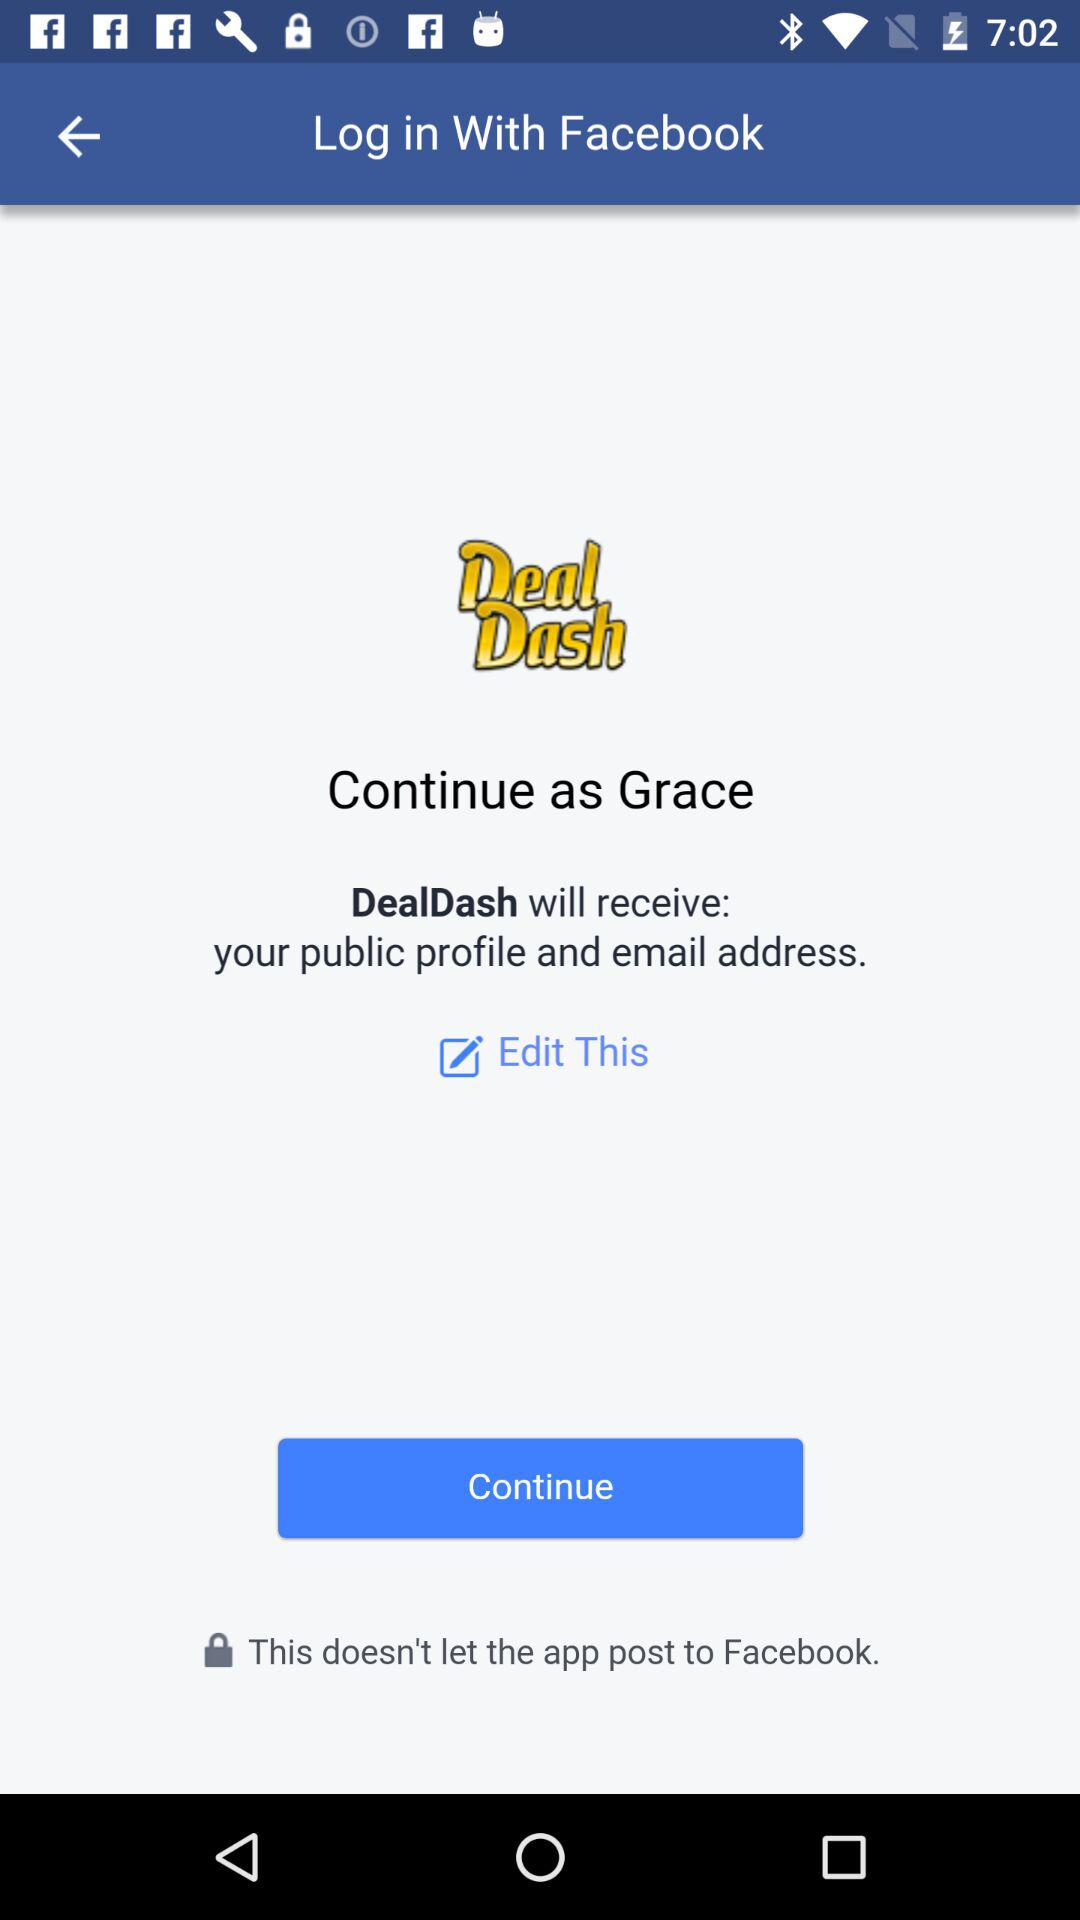Who will receive the public profile and email address? The public profile and email address will be received by "DealDash". 